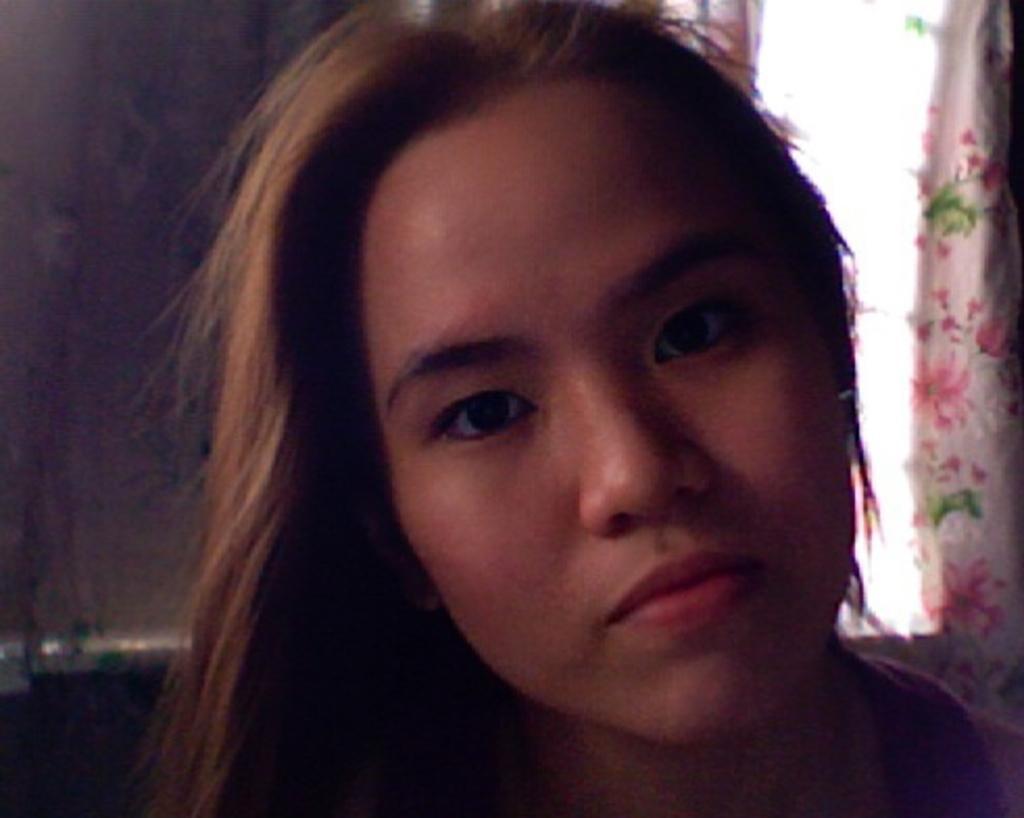Can you describe this image briefly? Here in this picture we can see a woman and behind her we can see a curtain present. 